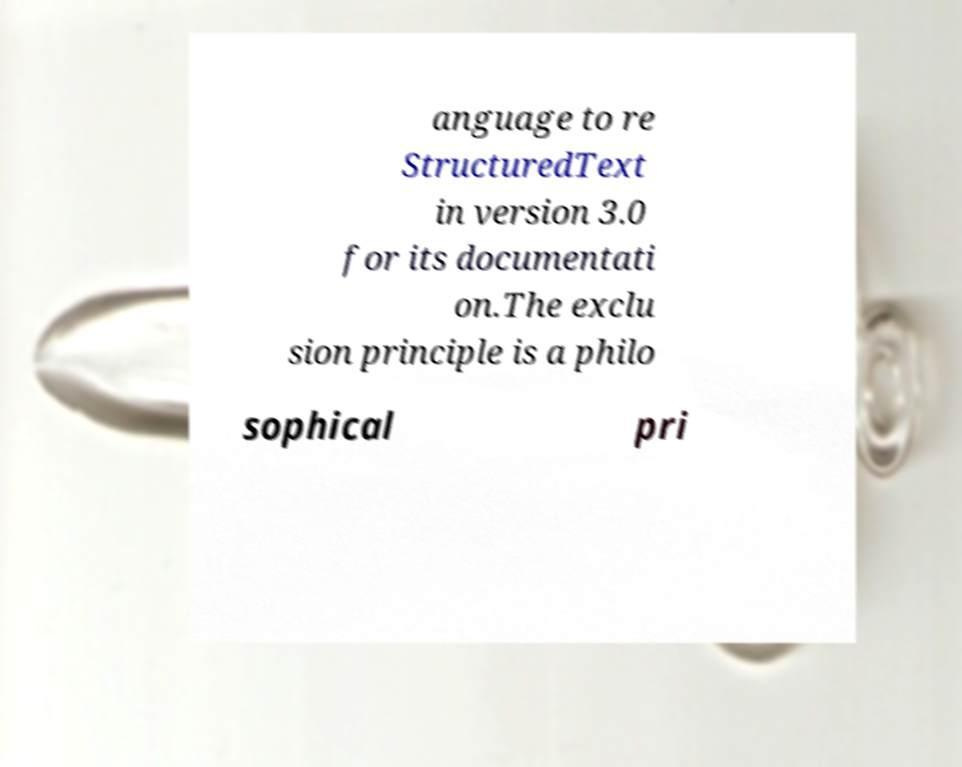Please identify and transcribe the text found in this image. anguage to re StructuredText in version 3.0 for its documentati on.The exclu sion principle is a philo sophical pri 